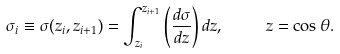<formula> <loc_0><loc_0><loc_500><loc_500>\sigma _ { i } \equiv \sigma ( z _ { i } , z _ { i + 1 } ) = \int _ { z _ { i } } ^ { z _ { i + 1 } } \left ( \frac { d \sigma } { d z } \right ) d z , \quad \ z = \cos \theta .</formula> 